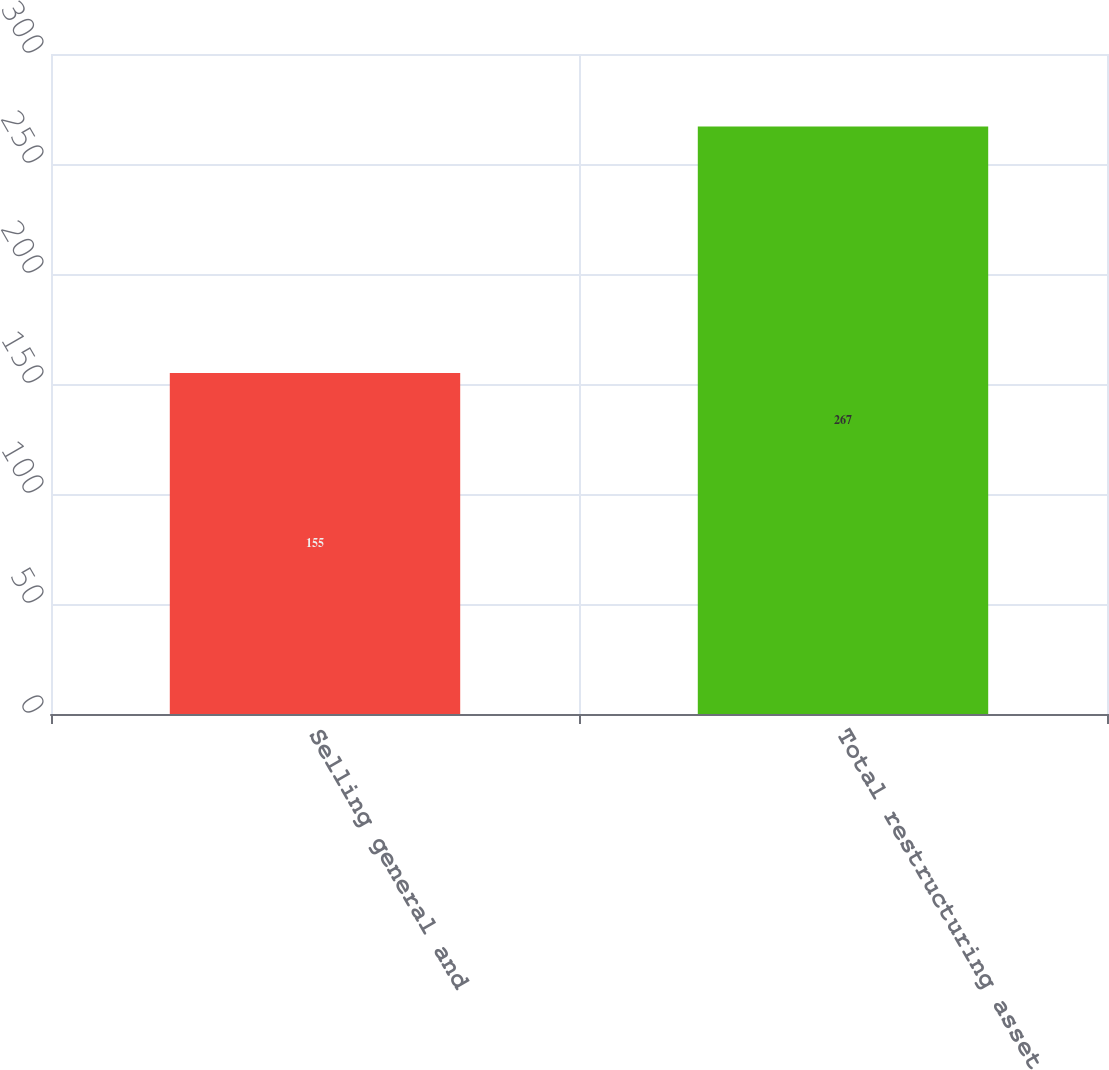<chart> <loc_0><loc_0><loc_500><loc_500><bar_chart><fcel>Selling general and<fcel>Total restructuring asset<nl><fcel>155<fcel>267<nl></chart> 